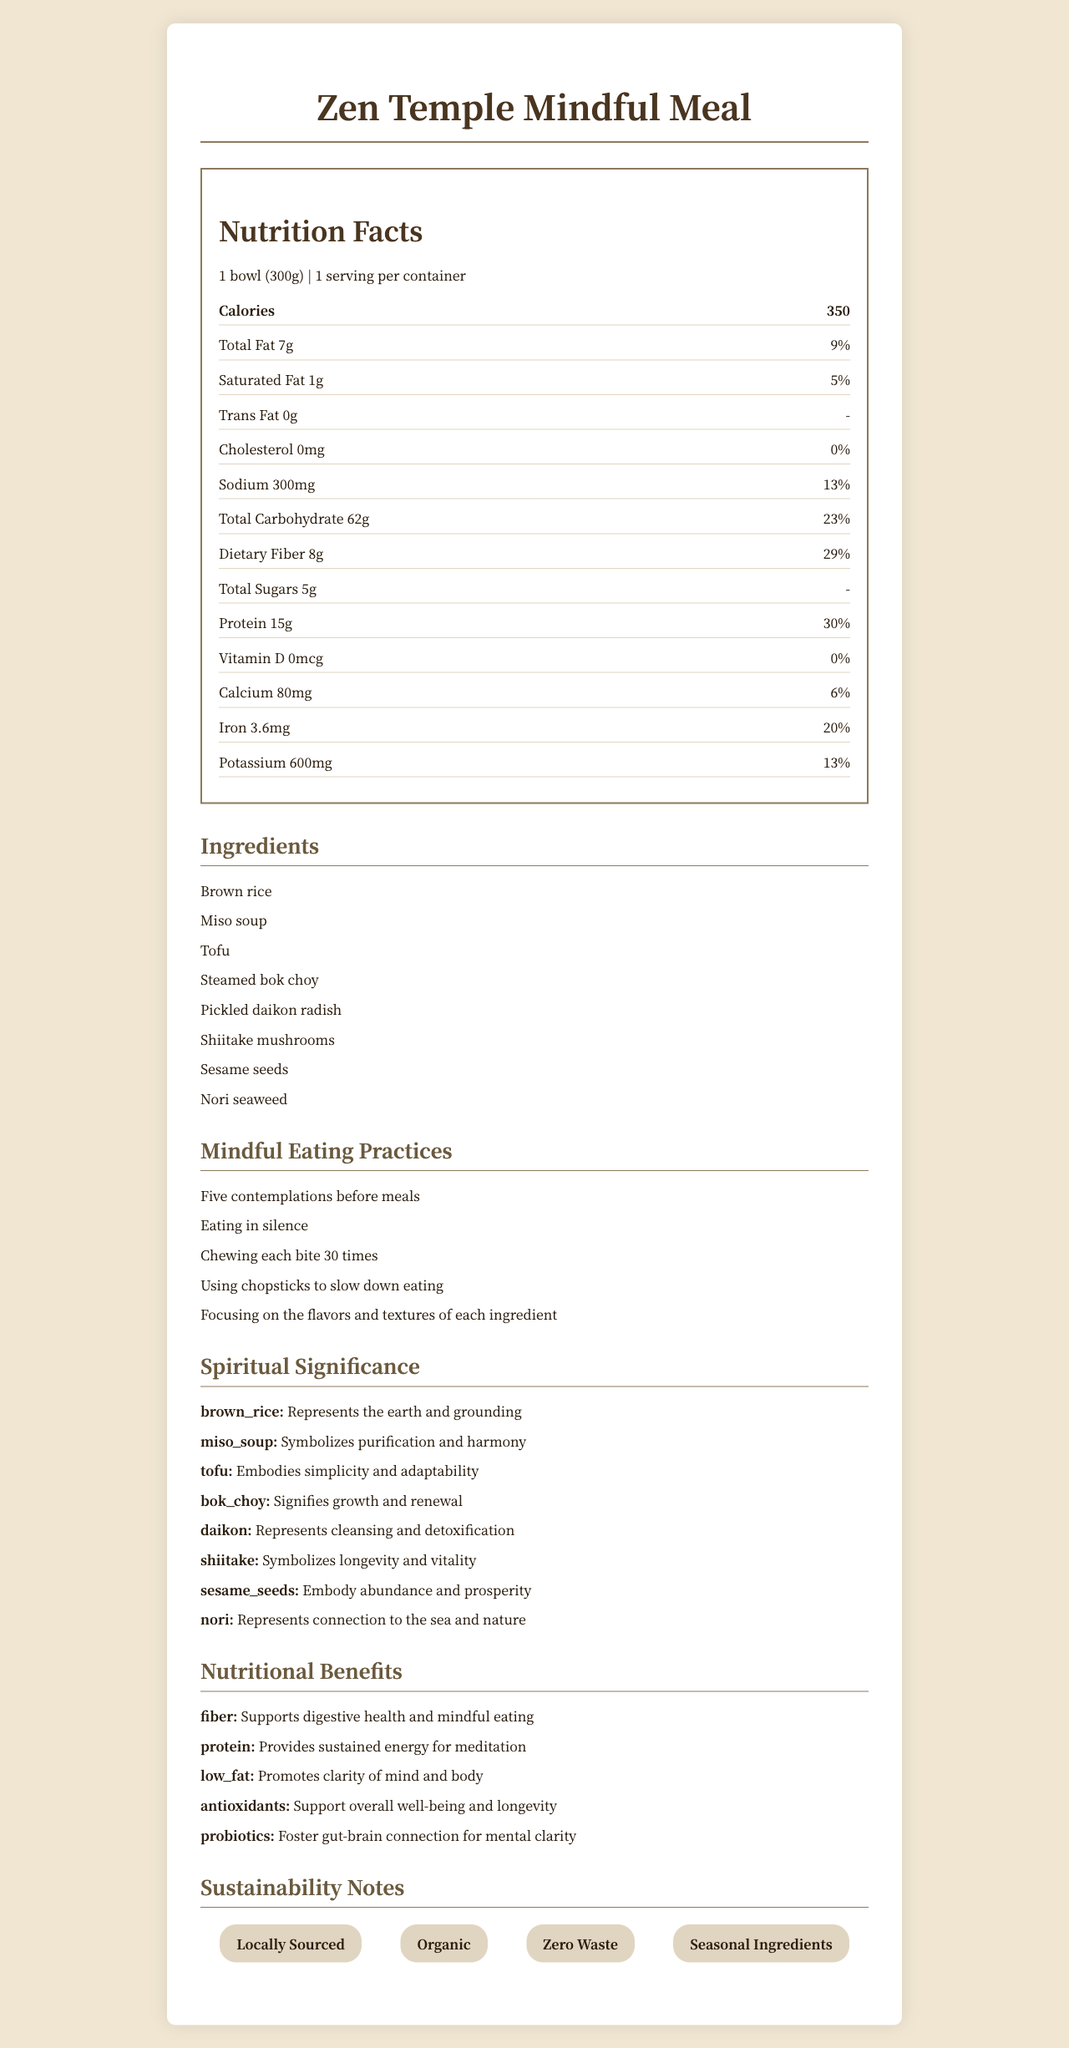what is the serving size of the Zen Temple Mindful Meal? The serving size is mentioned at the top of the nutrition label section.
Answer: 1 bowl (300g) how many calories are in a serving of the Zen Temple Mindful Meal? The calories are listed right after the serving size on the nutrition label.
Answer: 350 what ingredient represents purification and harmony? The spiritual significance section states that miso soup symbolizes purification and harmony.
Answer: Miso soup how much dietary fiber does this meal provide? The nutrition label lists dietary fiber as 8g per serving.
Answer: 8g what mindful eating practice encourages focusing on the flavors and textures of each ingredient? This practice is mentioned in the mindful eating practices section.
Answer: Focusing on the flavors and textures of each ingredient how much protein does the Zen Temple Mindful Meal contain? The amount of protein is listed in the nutrition label section.
Answer: 15g which ingredients are believed to embody abundance and prosperity? A. Shiitake mushrooms B. Brown rice C. Sesame seeds D. Nori seaweed The spiritual significance section indicates that sesame seeds embody abundance and prosperity.
Answer: C what is the daily value percentage of iron in this meal? A. 6% B. 13% C. 20% D. 30% The daily value percentage of iron is listed as 20% on the nutrition label.
Answer: C is the Zen Temple Mindful Meal cholesterol-free? The nutrition label indicates that the cholesterol amount is 0mg and the daily value is 0%.
Answer: Yes describe the main idea and content of the document. The document presents comprehensive details on various aspects of the Zen Temple Mindful Meal, aligning its nutritional information with spiritual and mindful eating practices.
Answer: The document provides detailed nutritional information, ingredients, mindful eating practices, spiritual significance, nutritional benefits, and sustainability notes for the Zen Temple Mindful Meal. It emphasizes the mindful and spiritual aspects of Buddhist temple cuisine. how does this meal support digestive health? The nutritional benefits section mentions that dietary fiber supports digestive health and mindful eating.
Answer: Dietary fiber what is not enough information? The document does not specify if the Zen Temple Mindful Meal is gluten-free or contains gluten ingredients.
Answer: Whether the meal is gluten-free 